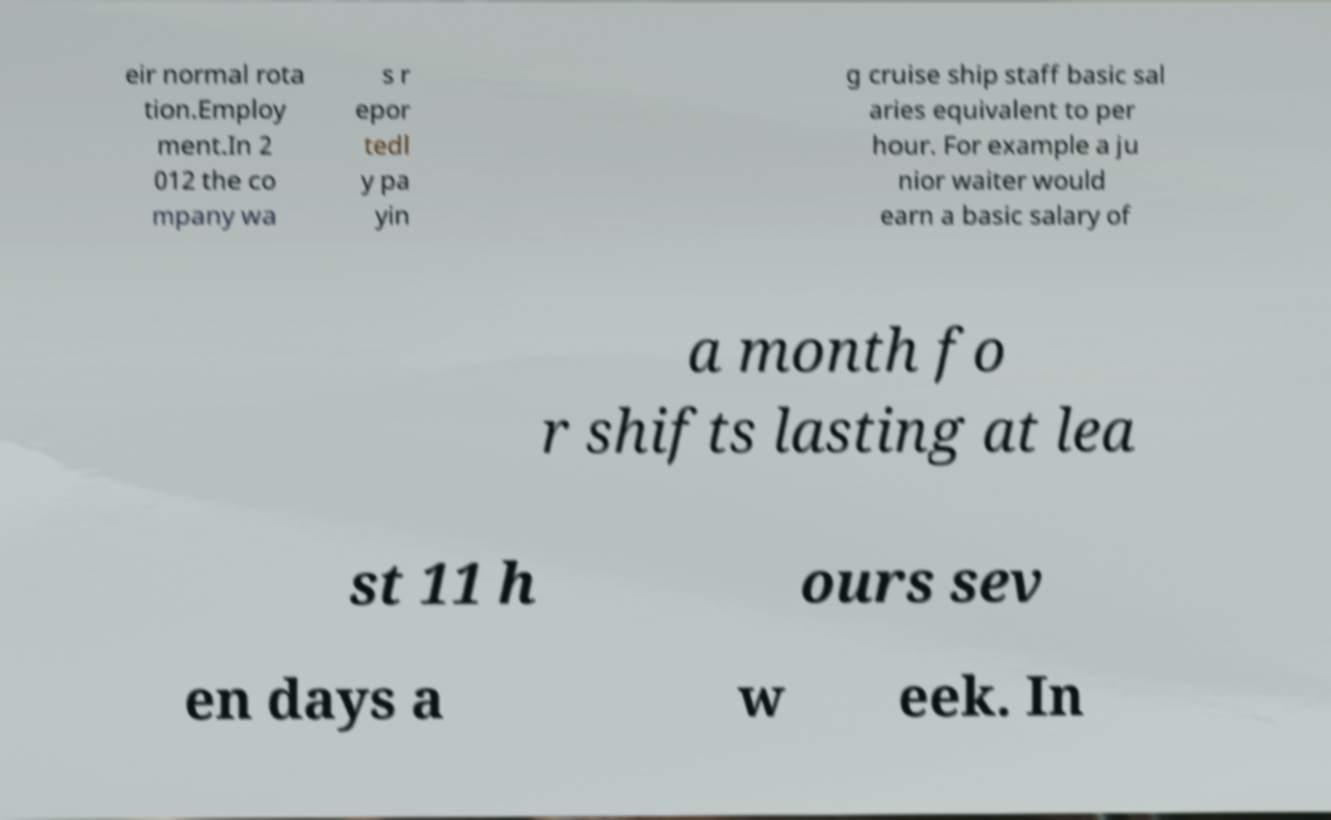I need the written content from this picture converted into text. Can you do that? eir normal rota tion.Employ ment.In 2 012 the co mpany wa s r epor tedl y pa yin g cruise ship staff basic sal aries equivalent to per hour. For example a ju nior waiter would earn a basic salary of a month fo r shifts lasting at lea st 11 h ours sev en days a w eek. In 